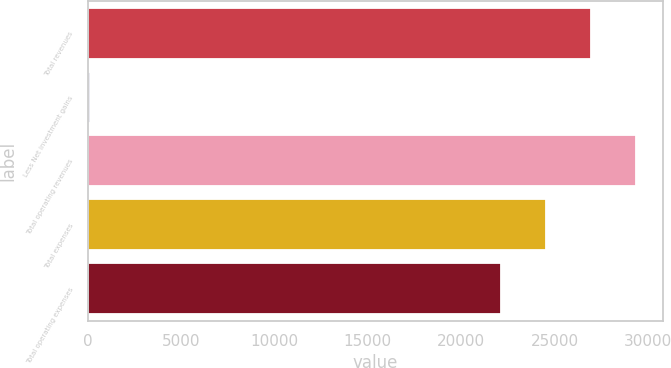Convert chart to OTSL. <chart><loc_0><loc_0><loc_500><loc_500><bar_chart><fcel>Total revenues<fcel>Less Net investment gains<fcel>Total operating revenues<fcel>Total expenses<fcel>Total operating expenses<nl><fcel>26950.6<fcel>121<fcel>29360.4<fcel>24540.8<fcel>22131<nl></chart> 